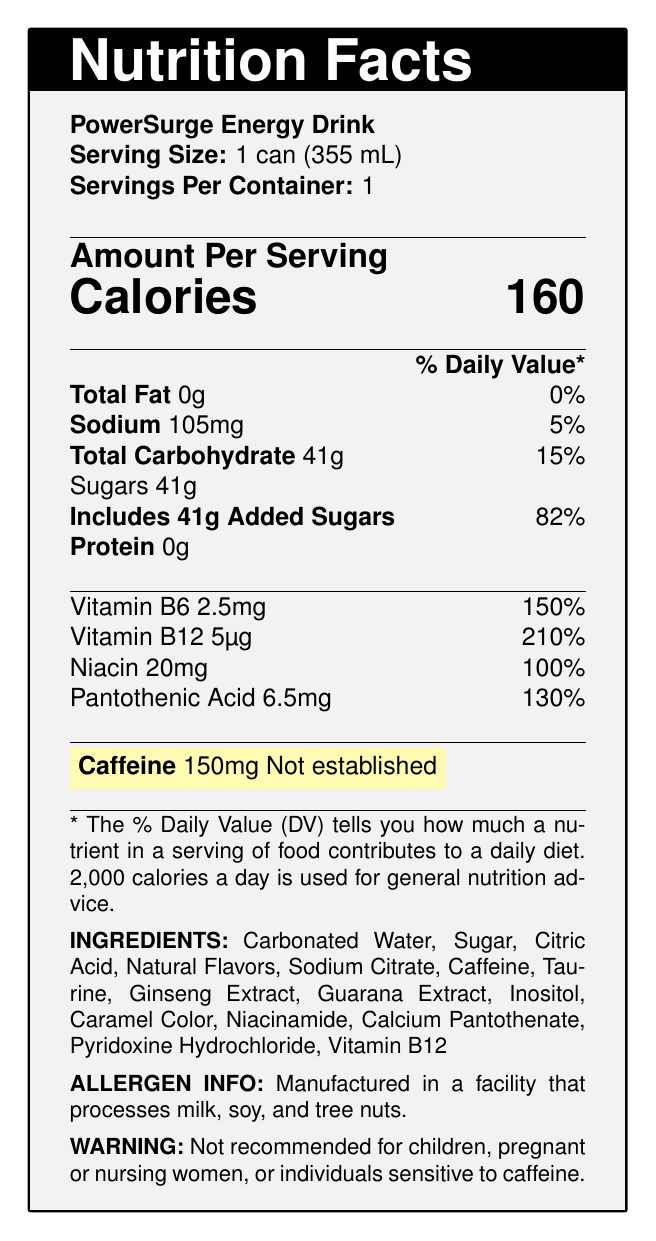what is the serving size of the PowerSurge Energy Drink? The serving size is clearly mentioned as "1 can (355 mL)" in the document.
Answer: 1 can (355 mL) how many calories are there per serving? The document states that each serving contains 160 calories.
Answer: 160 calories what is the amount of sodium per serving? According to the document, there is 105mg of sodium per serving.
Answer: 105mg what percentage of the daily value does the total carbohydrate content represent? The document indicates that the Total Carbohydrate content is 41g, which is 15% of the daily value.
Answer: 15% how much added sugar is included in the product? It is specified in the document that the product includes 41g of added sugars.
Answer: 41g which vitamin has the highest percentage of the daily value? A. Vitamin B6 B. Vitamin B12 C. Niacin D. Pantothenic Acid Vitamin B12 has a daily value percentage of 210%, which is the highest among the listed vitamins.
Answer: B. Vitamin B12 what is the amount of caffeine per serving? A. 100mg B. 120mg C. 150mg D. 180mg The document highlights that the amount of caffeine per serving is 150mg.
Answer: C. 150mg is the product recommended for children? The warning section of the document states that the product is not recommended for children.
Answer: No please summarize the information provided in the document. This summary captures the essential details of the nutrition facts label, including the key nutritional information, ingredient list, and important warnings.
Answer: The document is a nutrition facts label for PowerSurge Energy Drink, highlighting its serving size (1 can, 355 mL), 160 calories per serving, and various nutritional contents, including 41g of total carbohydrates (82% from added sugars), and 0g of total fat and protein. It lists vitamins such as Vitamin B6, B12, Niacin, and Pantothenic Acid with their respective daily values. The caffeine content is highlighted at 150mg. The label also includes a list of ingredients, allergen information, and a warning about consumption for certain individuals. does the product contain any protein? The document indicates that the product contains 0g of protein.
Answer: No how many servings are there per container? The document clearly states that there is 1 serving per container.
Answer: 1 what is the first ingredient listed on the ingredient list? The first ingredient listed is Carbonated Water.
Answer: Carbonated Water what is the percentage of daily value for Vitamin B6? The document indicates that Vitamin B6 has a daily value percentage of 150%.
Answer: 150% which allergen is processed in the manufacturing facility? The allergen information states that the product is manufactured in a facility that processes milk, soy, and tree nuts.
Answer: Milk, soy, and tree nuts is the caffeine content percentage of daily value established? The document explicitly mentions that the daily value percentage for caffeine is "Not established".
Answer: Not established what is the main flavoring agent in the product? The document lists "Natural Flavors" but does not specify what the main flavoring agent is.
Answer: Cannot be determined 